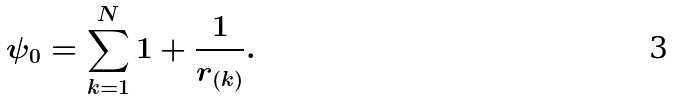Convert formula to latex. <formula><loc_0><loc_0><loc_500><loc_500>\psi _ { 0 } = \sum _ { k = 1 } ^ { N } 1 + \frac { 1 } { r _ { ( k ) } } .</formula> 